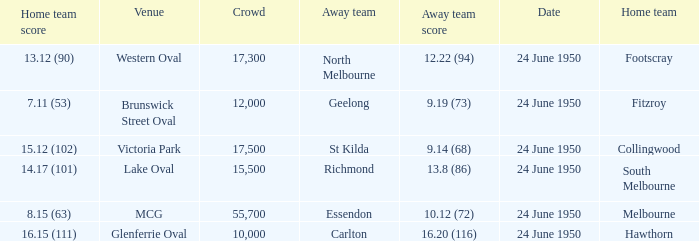When was the game where the away team had a score of 13.8 (86)? 24 June 1950. 